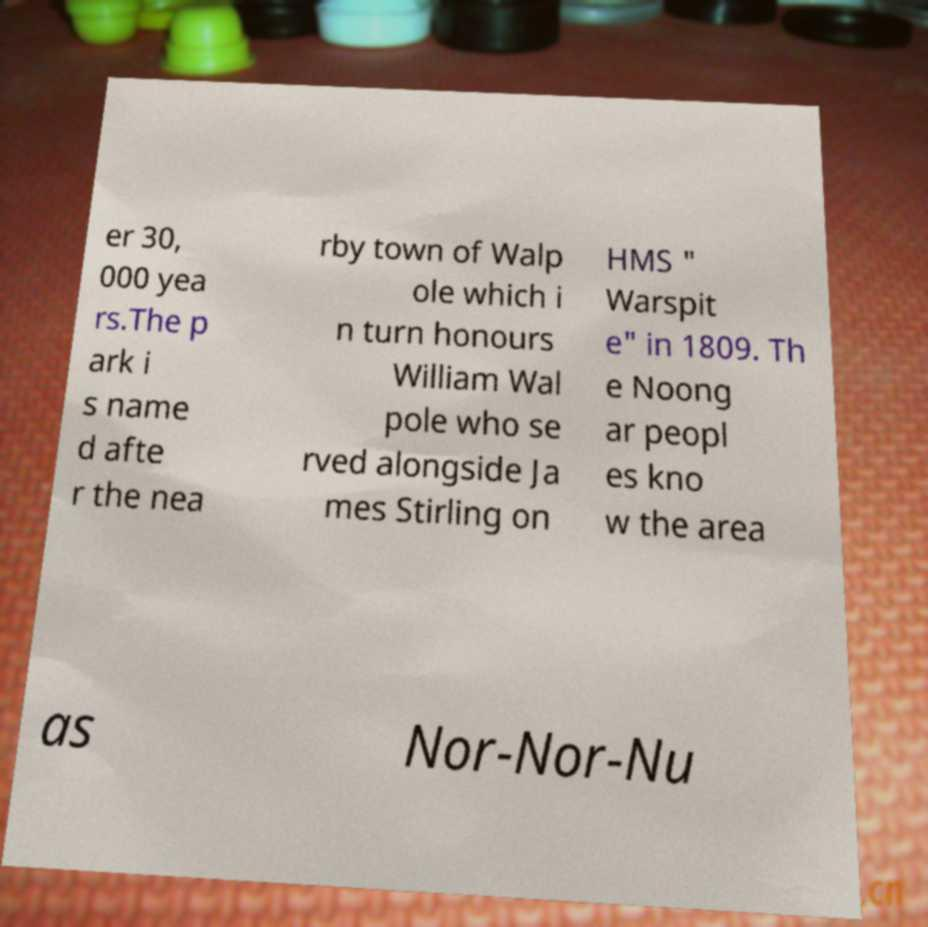Please read and relay the text visible in this image. What does it say? er 30, 000 yea rs.The p ark i s name d afte r the nea rby town of Walp ole which i n turn honours William Wal pole who se rved alongside Ja mes Stirling on HMS " Warspit e" in 1809. Th e Noong ar peopl es kno w the area as Nor-Nor-Nu 